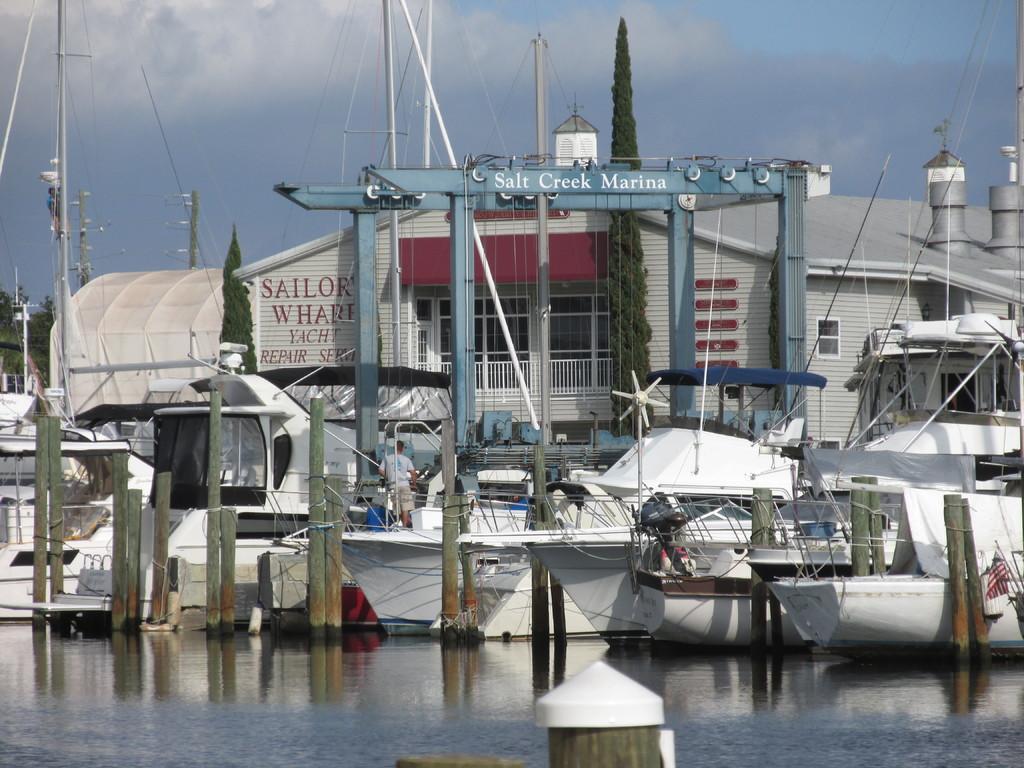What's the name of this marina?
Offer a terse response. Salt creek. What is a service this company performs?
Give a very brief answer. Yacht repair. 